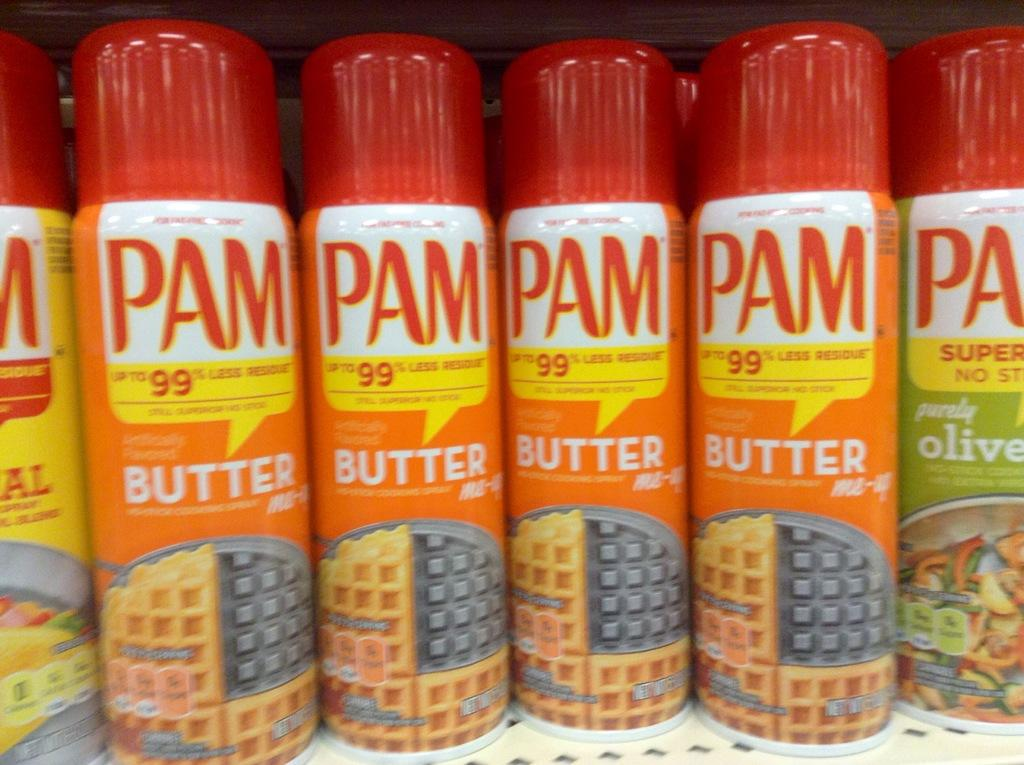What objects are arranged in a rack in the image? There are bottles arranged in a rack in the image. How are the bottles positioned in the image? The bottles are arranged in a rack. What might be the purpose of arranging the bottles in this manner? The arrangement of the bottles in a rack could be for storage, organization, or display purposes. What type of base is used for the stove in the image? There is no stove present in the image; it only features bottles arranged in a rack. What type of operation is being performed on the bottles in the image? There is no operation being performed on the bottles in the image; they are simply arranged in a rack. 